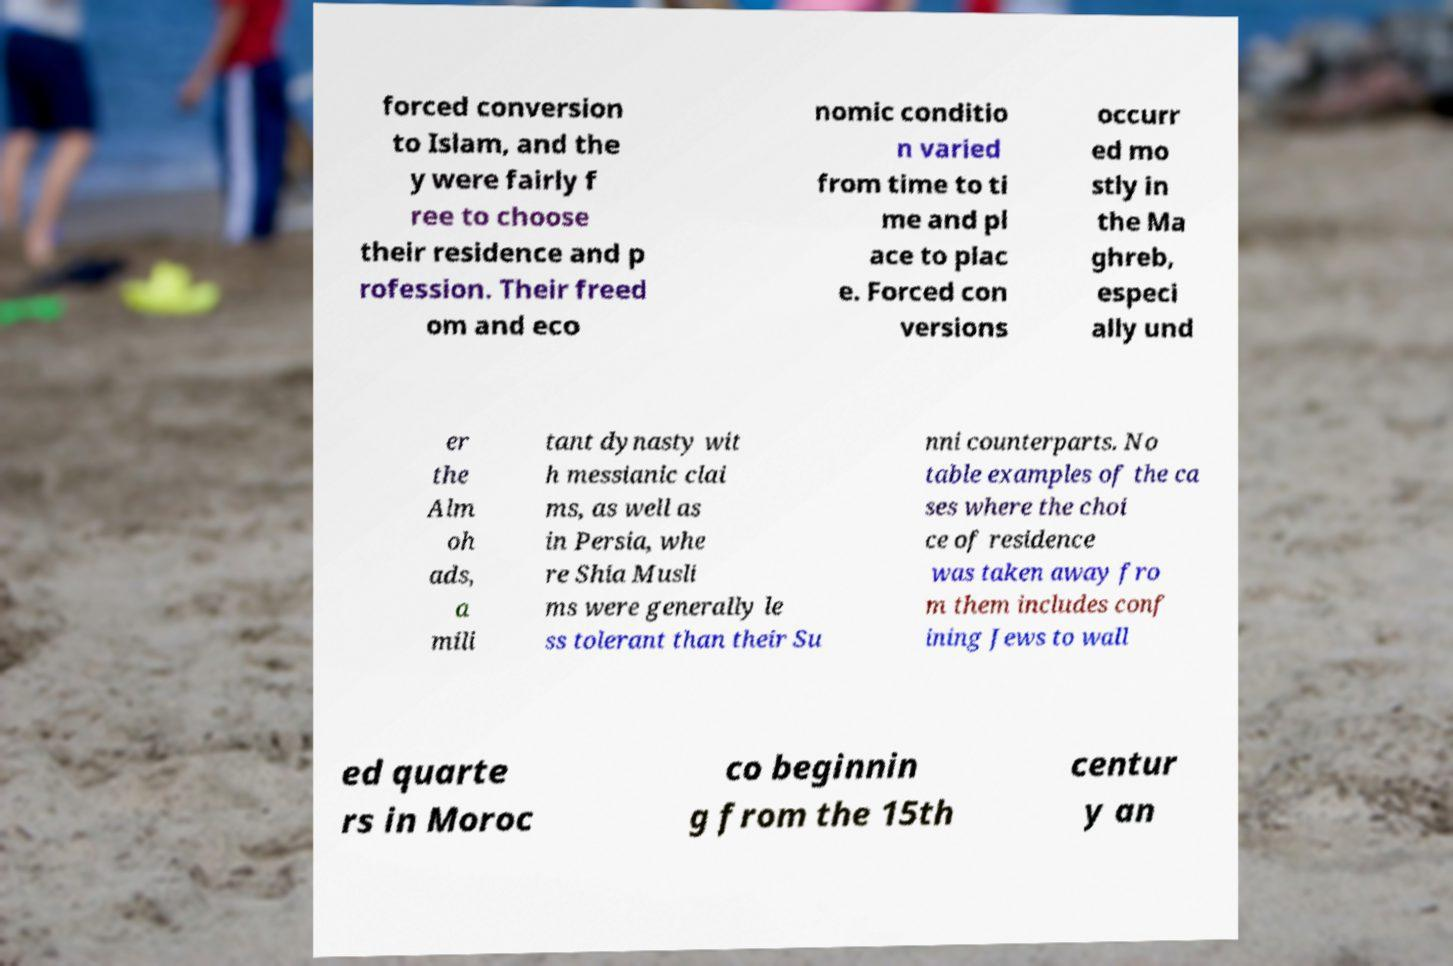Can you read and provide the text displayed in the image?This photo seems to have some interesting text. Can you extract and type it out for me? forced conversion to Islam, and the y were fairly f ree to choose their residence and p rofession. Their freed om and eco nomic conditio n varied from time to ti me and pl ace to plac e. Forced con versions occurr ed mo stly in the Ma ghreb, especi ally und er the Alm oh ads, a mili tant dynasty wit h messianic clai ms, as well as in Persia, whe re Shia Musli ms were generally le ss tolerant than their Su nni counterparts. No table examples of the ca ses where the choi ce of residence was taken away fro m them includes conf ining Jews to wall ed quarte rs in Moroc co beginnin g from the 15th centur y an 